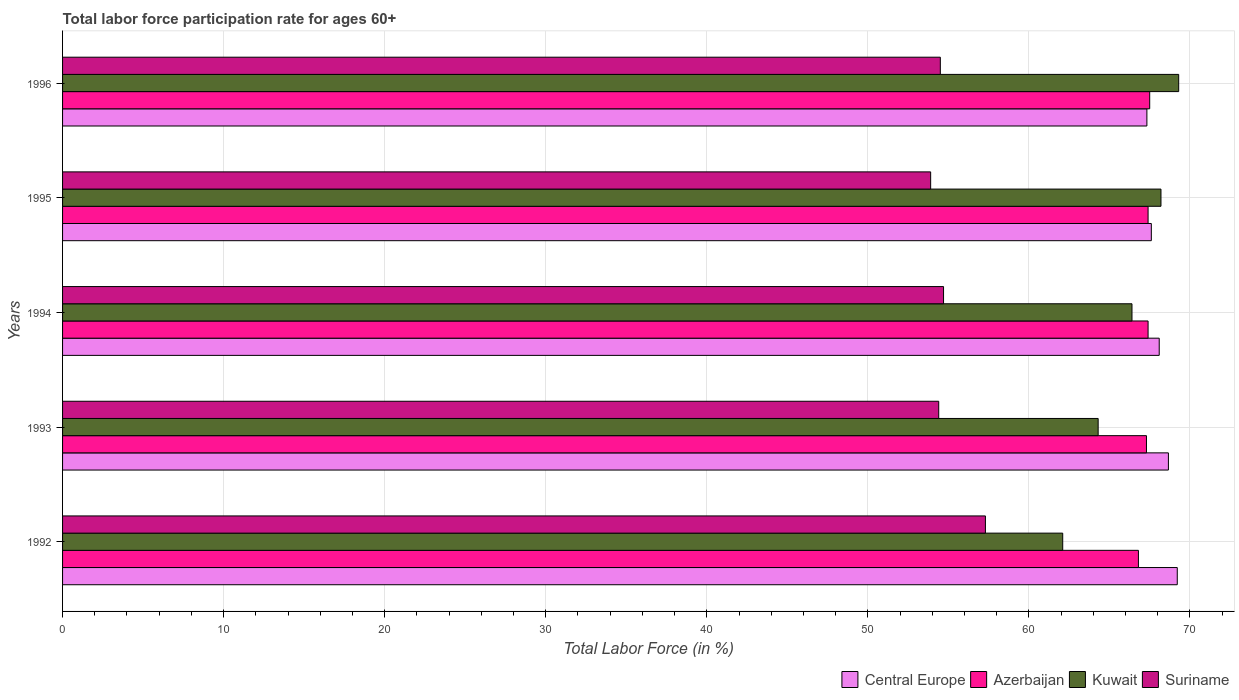How many different coloured bars are there?
Keep it short and to the point. 4. How many groups of bars are there?
Your response must be concise. 5. Are the number of bars per tick equal to the number of legend labels?
Offer a very short reply. Yes. How many bars are there on the 1st tick from the top?
Ensure brevity in your answer.  4. How many bars are there on the 3rd tick from the bottom?
Make the answer very short. 4. In how many cases, is the number of bars for a given year not equal to the number of legend labels?
Provide a succinct answer. 0. What is the labor force participation rate in Suriname in 1993?
Your answer should be very brief. 54.4. Across all years, what is the maximum labor force participation rate in Kuwait?
Make the answer very short. 69.3. Across all years, what is the minimum labor force participation rate in Suriname?
Your answer should be very brief. 53.9. In which year was the labor force participation rate in Kuwait maximum?
Provide a succinct answer. 1996. In which year was the labor force participation rate in Central Europe minimum?
Keep it short and to the point. 1996. What is the total labor force participation rate in Azerbaijan in the graph?
Your answer should be compact. 336.4. What is the difference between the labor force participation rate in Suriname in 1994 and that in 1996?
Provide a succinct answer. 0.2. What is the difference between the labor force participation rate in Kuwait in 1994 and the labor force participation rate in Central Europe in 1996?
Your response must be concise. -0.93. What is the average labor force participation rate in Central Europe per year?
Your answer should be very brief. 68.18. In the year 1996, what is the difference between the labor force participation rate in Azerbaijan and labor force participation rate in Suriname?
Your answer should be very brief. 13. In how many years, is the labor force participation rate in Central Europe greater than 38 %?
Offer a terse response. 5. What is the ratio of the labor force participation rate in Azerbaijan in 1992 to that in 1996?
Offer a very short reply. 0.99. Is the difference between the labor force participation rate in Azerbaijan in 1995 and 1996 greater than the difference between the labor force participation rate in Suriname in 1995 and 1996?
Provide a short and direct response. Yes. What is the difference between the highest and the second highest labor force participation rate in Central Europe?
Provide a short and direct response. 0.55. What is the difference between the highest and the lowest labor force participation rate in Kuwait?
Make the answer very short. 7.2. Is it the case that in every year, the sum of the labor force participation rate in Central Europe and labor force participation rate in Suriname is greater than the sum of labor force participation rate in Kuwait and labor force participation rate in Azerbaijan?
Your answer should be compact. Yes. What does the 3rd bar from the top in 1992 represents?
Make the answer very short. Azerbaijan. What does the 4th bar from the bottom in 1992 represents?
Offer a very short reply. Suriname. How many bars are there?
Offer a very short reply. 20. How many years are there in the graph?
Give a very brief answer. 5. What is the difference between two consecutive major ticks on the X-axis?
Ensure brevity in your answer.  10. Are the values on the major ticks of X-axis written in scientific E-notation?
Keep it short and to the point. No. Does the graph contain any zero values?
Offer a terse response. No. Does the graph contain grids?
Your answer should be compact. Yes. Where does the legend appear in the graph?
Your answer should be compact. Bottom right. How are the legend labels stacked?
Keep it short and to the point. Horizontal. What is the title of the graph?
Ensure brevity in your answer.  Total labor force participation rate for ages 60+. What is the label or title of the X-axis?
Make the answer very short. Total Labor Force (in %). What is the label or title of the Y-axis?
Make the answer very short. Years. What is the Total Labor Force (in %) of Central Europe in 1992?
Your answer should be very brief. 69.21. What is the Total Labor Force (in %) of Azerbaijan in 1992?
Offer a terse response. 66.8. What is the Total Labor Force (in %) in Kuwait in 1992?
Make the answer very short. 62.1. What is the Total Labor Force (in %) in Suriname in 1992?
Make the answer very short. 57.3. What is the Total Labor Force (in %) in Central Europe in 1993?
Your answer should be very brief. 68.66. What is the Total Labor Force (in %) in Azerbaijan in 1993?
Keep it short and to the point. 67.3. What is the Total Labor Force (in %) of Kuwait in 1993?
Your answer should be compact. 64.3. What is the Total Labor Force (in %) in Suriname in 1993?
Offer a terse response. 54.4. What is the Total Labor Force (in %) of Central Europe in 1994?
Your answer should be very brief. 68.09. What is the Total Labor Force (in %) of Azerbaijan in 1994?
Your response must be concise. 67.4. What is the Total Labor Force (in %) of Kuwait in 1994?
Give a very brief answer. 66.4. What is the Total Labor Force (in %) of Suriname in 1994?
Offer a terse response. 54.7. What is the Total Labor Force (in %) of Central Europe in 1995?
Keep it short and to the point. 67.6. What is the Total Labor Force (in %) of Azerbaijan in 1995?
Make the answer very short. 67.4. What is the Total Labor Force (in %) in Kuwait in 1995?
Your answer should be very brief. 68.2. What is the Total Labor Force (in %) of Suriname in 1995?
Keep it short and to the point. 53.9. What is the Total Labor Force (in %) of Central Europe in 1996?
Offer a terse response. 67.33. What is the Total Labor Force (in %) in Azerbaijan in 1996?
Provide a short and direct response. 67.5. What is the Total Labor Force (in %) in Kuwait in 1996?
Make the answer very short. 69.3. What is the Total Labor Force (in %) in Suriname in 1996?
Provide a succinct answer. 54.5. Across all years, what is the maximum Total Labor Force (in %) of Central Europe?
Your answer should be compact. 69.21. Across all years, what is the maximum Total Labor Force (in %) in Azerbaijan?
Offer a terse response. 67.5. Across all years, what is the maximum Total Labor Force (in %) of Kuwait?
Offer a terse response. 69.3. Across all years, what is the maximum Total Labor Force (in %) in Suriname?
Provide a short and direct response. 57.3. Across all years, what is the minimum Total Labor Force (in %) of Central Europe?
Keep it short and to the point. 67.33. Across all years, what is the minimum Total Labor Force (in %) of Azerbaijan?
Provide a succinct answer. 66.8. Across all years, what is the minimum Total Labor Force (in %) in Kuwait?
Offer a very short reply. 62.1. Across all years, what is the minimum Total Labor Force (in %) in Suriname?
Keep it short and to the point. 53.9. What is the total Total Labor Force (in %) in Central Europe in the graph?
Keep it short and to the point. 340.89. What is the total Total Labor Force (in %) in Azerbaijan in the graph?
Offer a terse response. 336.4. What is the total Total Labor Force (in %) of Kuwait in the graph?
Make the answer very short. 330.3. What is the total Total Labor Force (in %) in Suriname in the graph?
Offer a terse response. 274.8. What is the difference between the Total Labor Force (in %) in Central Europe in 1992 and that in 1993?
Your answer should be compact. 0.55. What is the difference between the Total Labor Force (in %) in Azerbaijan in 1992 and that in 1993?
Keep it short and to the point. -0.5. What is the difference between the Total Labor Force (in %) in Central Europe in 1992 and that in 1994?
Your answer should be compact. 1.12. What is the difference between the Total Labor Force (in %) in Azerbaijan in 1992 and that in 1994?
Keep it short and to the point. -0.6. What is the difference between the Total Labor Force (in %) of Kuwait in 1992 and that in 1994?
Offer a terse response. -4.3. What is the difference between the Total Labor Force (in %) of Central Europe in 1992 and that in 1995?
Your answer should be very brief. 1.61. What is the difference between the Total Labor Force (in %) in Kuwait in 1992 and that in 1995?
Offer a very short reply. -6.1. What is the difference between the Total Labor Force (in %) of Suriname in 1992 and that in 1995?
Your answer should be very brief. 3.4. What is the difference between the Total Labor Force (in %) in Central Europe in 1992 and that in 1996?
Provide a succinct answer. 1.89. What is the difference between the Total Labor Force (in %) of Azerbaijan in 1992 and that in 1996?
Make the answer very short. -0.7. What is the difference between the Total Labor Force (in %) in Central Europe in 1993 and that in 1994?
Your answer should be compact. 0.57. What is the difference between the Total Labor Force (in %) of Azerbaijan in 1993 and that in 1994?
Provide a short and direct response. -0.1. What is the difference between the Total Labor Force (in %) of Kuwait in 1993 and that in 1994?
Offer a very short reply. -2.1. What is the difference between the Total Labor Force (in %) of Suriname in 1993 and that in 1994?
Ensure brevity in your answer.  -0.3. What is the difference between the Total Labor Force (in %) of Central Europe in 1993 and that in 1995?
Offer a very short reply. 1.06. What is the difference between the Total Labor Force (in %) in Kuwait in 1993 and that in 1995?
Your answer should be very brief. -3.9. What is the difference between the Total Labor Force (in %) in Central Europe in 1993 and that in 1996?
Make the answer very short. 1.34. What is the difference between the Total Labor Force (in %) of Azerbaijan in 1993 and that in 1996?
Give a very brief answer. -0.2. What is the difference between the Total Labor Force (in %) in Kuwait in 1993 and that in 1996?
Your answer should be compact. -5. What is the difference between the Total Labor Force (in %) of Suriname in 1993 and that in 1996?
Ensure brevity in your answer.  -0.1. What is the difference between the Total Labor Force (in %) of Central Europe in 1994 and that in 1995?
Offer a very short reply. 0.49. What is the difference between the Total Labor Force (in %) of Kuwait in 1994 and that in 1995?
Keep it short and to the point. -1.8. What is the difference between the Total Labor Force (in %) of Central Europe in 1994 and that in 1996?
Offer a very short reply. 0.77. What is the difference between the Total Labor Force (in %) in Kuwait in 1994 and that in 1996?
Offer a very short reply. -2.9. What is the difference between the Total Labor Force (in %) of Suriname in 1994 and that in 1996?
Offer a very short reply. 0.2. What is the difference between the Total Labor Force (in %) of Central Europe in 1995 and that in 1996?
Offer a terse response. 0.28. What is the difference between the Total Labor Force (in %) in Azerbaijan in 1995 and that in 1996?
Provide a succinct answer. -0.1. What is the difference between the Total Labor Force (in %) in Central Europe in 1992 and the Total Labor Force (in %) in Azerbaijan in 1993?
Offer a very short reply. 1.91. What is the difference between the Total Labor Force (in %) in Central Europe in 1992 and the Total Labor Force (in %) in Kuwait in 1993?
Your response must be concise. 4.91. What is the difference between the Total Labor Force (in %) of Central Europe in 1992 and the Total Labor Force (in %) of Suriname in 1993?
Ensure brevity in your answer.  14.81. What is the difference between the Total Labor Force (in %) in Azerbaijan in 1992 and the Total Labor Force (in %) in Kuwait in 1993?
Provide a succinct answer. 2.5. What is the difference between the Total Labor Force (in %) in Azerbaijan in 1992 and the Total Labor Force (in %) in Suriname in 1993?
Keep it short and to the point. 12.4. What is the difference between the Total Labor Force (in %) in Central Europe in 1992 and the Total Labor Force (in %) in Azerbaijan in 1994?
Offer a very short reply. 1.81. What is the difference between the Total Labor Force (in %) of Central Europe in 1992 and the Total Labor Force (in %) of Kuwait in 1994?
Give a very brief answer. 2.81. What is the difference between the Total Labor Force (in %) in Central Europe in 1992 and the Total Labor Force (in %) in Suriname in 1994?
Make the answer very short. 14.51. What is the difference between the Total Labor Force (in %) of Central Europe in 1992 and the Total Labor Force (in %) of Azerbaijan in 1995?
Your answer should be very brief. 1.81. What is the difference between the Total Labor Force (in %) in Central Europe in 1992 and the Total Labor Force (in %) in Suriname in 1995?
Keep it short and to the point. 15.31. What is the difference between the Total Labor Force (in %) in Central Europe in 1992 and the Total Labor Force (in %) in Azerbaijan in 1996?
Keep it short and to the point. 1.71. What is the difference between the Total Labor Force (in %) of Central Europe in 1992 and the Total Labor Force (in %) of Kuwait in 1996?
Make the answer very short. -0.09. What is the difference between the Total Labor Force (in %) of Central Europe in 1992 and the Total Labor Force (in %) of Suriname in 1996?
Ensure brevity in your answer.  14.71. What is the difference between the Total Labor Force (in %) in Azerbaijan in 1992 and the Total Labor Force (in %) in Suriname in 1996?
Ensure brevity in your answer.  12.3. What is the difference between the Total Labor Force (in %) of Kuwait in 1992 and the Total Labor Force (in %) of Suriname in 1996?
Offer a terse response. 7.6. What is the difference between the Total Labor Force (in %) of Central Europe in 1993 and the Total Labor Force (in %) of Azerbaijan in 1994?
Make the answer very short. 1.26. What is the difference between the Total Labor Force (in %) in Central Europe in 1993 and the Total Labor Force (in %) in Kuwait in 1994?
Offer a very short reply. 2.26. What is the difference between the Total Labor Force (in %) of Central Europe in 1993 and the Total Labor Force (in %) of Suriname in 1994?
Provide a short and direct response. 13.96. What is the difference between the Total Labor Force (in %) in Azerbaijan in 1993 and the Total Labor Force (in %) in Kuwait in 1994?
Make the answer very short. 0.9. What is the difference between the Total Labor Force (in %) of Azerbaijan in 1993 and the Total Labor Force (in %) of Suriname in 1994?
Keep it short and to the point. 12.6. What is the difference between the Total Labor Force (in %) of Central Europe in 1993 and the Total Labor Force (in %) of Azerbaijan in 1995?
Provide a short and direct response. 1.26. What is the difference between the Total Labor Force (in %) in Central Europe in 1993 and the Total Labor Force (in %) in Kuwait in 1995?
Ensure brevity in your answer.  0.46. What is the difference between the Total Labor Force (in %) in Central Europe in 1993 and the Total Labor Force (in %) in Suriname in 1995?
Your answer should be very brief. 14.76. What is the difference between the Total Labor Force (in %) of Kuwait in 1993 and the Total Labor Force (in %) of Suriname in 1995?
Keep it short and to the point. 10.4. What is the difference between the Total Labor Force (in %) in Central Europe in 1993 and the Total Labor Force (in %) in Azerbaijan in 1996?
Provide a short and direct response. 1.16. What is the difference between the Total Labor Force (in %) in Central Europe in 1993 and the Total Labor Force (in %) in Kuwait in 1996?
Provide a succinct answer. -0.64. What is the difference between the Total Labor Force (in %) of Central Europe in 1993 and the Total Labor Force (in %) of Suriname in 1996?
Make the answer very short. 14.16. What is the difference between the Total Labor Force (in %) of Azerbaijan in 1993 and the Total Labor Force (in %) of Suriname in 1996?
Your response must be concise. 12.8. What is the difference between the Total Labor Force (in %) in Central Europe in 1994 and the Total Labor Force (in %) in Azerbaijan in 1995?
Your response must be concise. 0.69. What is the difference between the Total Labor Force (in %) of Central Europe in 1994 and the Total Labor Force (in %) of Kuwait in 1995?
Ensure brevity in your answer.  -0.11. What is the difference between the Total Labor Force (in %) of Central Europe in 1994 and the Total Labor Force (in %) of Suriname in 1995?
Provide a succinct answer. 14.19. What is the difference between the Total Labor Force (in %) of Azerbaijan in 1994 and the Total Labor Force (in %) of Kuwait in 1995?
Your answer should be very brief. -0.8. What is the difference between the Total Labor Force (in %) in Azerbaijan in 1994 and the Total Labor Force (in %) in Suriname in 1995?
Offer a terse response. 13.5. What is the difference between the Total Labor Force (in %) of Central Europe in 1994 and the Total Labor Force (in %) of Azerbaijan in 1996?
Your response must be concise. 0.59. What is the difference between the Total Labor Force (in %) in Central Europe in 1994 and the Total Labor Force (in %) in Kuwait in 1996?
Provide a succinct answer. -1.21. What is the difference between the Total Labor Force (in %) in Central Europe in 1994 and the Total Labor Force (in %) in Suriname in 1996?
Make the answer very short. 13.59. What is the difference between the Total Labor Force (in %) of Central Europe in 1995 and the Total Labor Force (in %) of Azerbaijan in 1996?
Your answer should be very brief. 0.1. What is the difference between the Total Labor Force (in %) in Central Europe in 1995 and the Total Labor Force (in %) in Kuwait in 1996?
Your answer should be very brief. -1.7. What is the difference between the Total Labor Force (in %) of Central Europe in 1995 and the Total Labor Force (in %) of Suriname in 1996?
Keep it short and to the point. 13.1. What is the difference between the Total Labor Force (in %) of Azerbaijan in 1995 and the Total Labor Force (in %) of Kuwait in 1996?
Offer a very short reply. -1.9. What is the difference between the Total Labor Force (in %) of Azerbaijan in 1995 and the Total Labor Force (in %) of Suriname in 1996?
Offer a very short reply. 12.9. What is the difference between the Total Labor Force (in %) of Kuwait in 1995 and the Total Labor Force (in %) of Suriname in 1996?
Your answer should be compact. 13.7. What is the average Total Labor Force (in %) of Central Europe per year?
Offer a very short reply. 68.18. What is the average Total Labor Force (in %) in Azerbaijan per year?
Offer a very short reply. 67.28. What is the average Total Labor Force (in %) of Kuwait per year?
Your answer should be compact. 66.06. What is the average Total Labor Force (in %) in Suriname per year?
Ensure brevity in your answer.  54.96. In the year 1992, what is the difference between the Total Labor Force (in %) in Central Europe and Total Labor Force (in %) in Azerbaijan?
Provide a succinct answer. 2.41. In the year 1992, what is the difference between the Total Labor Force (in %) in Central Europe and Total Labor Force (in %) in Kuwait?
Ensure brevity in your answer.  7.11. In the year 1992, what is the difference between the Total Labor Force (in %) of Central Europe and Total Labor Force (in %) of Suriname?
Your answer should be very brief. 11.91. In the year 1992, what is the difference between the Total Labor Force (in %) of Azerbaijan and Total Labor Force (in %) of Suriname?
Make the answer very short. 9.5. In the year 1992, what is the difference between the Total Labor Force (in %) in Kuwait and Total Labor Force (in %) in Suriname?
Provide a succinct answer. 4.8. In the year 1993, what is the difference between the Total Labor Force (in %) in Central Europe and Total Labor Force (in %) in Azerbaijan?
Your answer should be compact. 1.36. In the year 1993, what is the difference between the Total Labor Force (in %) in Central Europe and Total Labor Force (in %) in Kuwait?
Provide a succinct answer. 4.36. In the year 1993, what is the difference between the Total Labor Force (in %) in Central Europe and Total Labor Force (in %) in Suriname?
Keep it short and to the point. 14.26. In the year 1993, what is the difference between the Total Labor Force (in %) in Azerbaijan and Total Labor Force (in %) in Suriname?
Your answer should be very brief. 12.9. In the year 1994, what is the difference between the Total Labor Force (in %) of Central Europe and Total Labor Force (in %) of Azerbaijan?
Give a very brief answer. 0.69. In the year 1994, what is the difference between the Total Labor Force (in %) in Central Europe and Total Labor Force (in %) in Kuwait?
Offer a very short reply. 1.69. In the year 1994, what is the difference between the Total Labor Force (in %) of Central Europe and Total Labor Force (in %) of Suriname?
Your response must be concise. 13.39. In the year 1994, what is the difference between the Total Labor Force (in %) in Azerbaijan and Total Labor Force (in %) in Suriname?
Keep it short and to the point. 12.7. In the year 1995, what is the difference between the Total Labor Force (in %) in Central Europe and Total Labor Force (in %) in Azerbaijan?
Your answer should be compact. 0.2. In the year 1995, what is the difference between the Total Labor Force (in %) of Central Europe and Total Labor Force (in %) of Kuwait?
Provide a short and direct response. -0.6. In the year 1995, what is the difference between the Total Labor Force (in %) in Central Europe and Total Labor Force (in %) in Suriname?
Offer a terse response. 13.7. In the year 1995, what is the difference between the Total Labor Force (in %) in Azerbaijan and Total Labor Force (in %) in Suriname?
Your answer should be very brief. 13.5. In the year 1995, what is the difference between the Total Labor Force (in %) of Kuwait and Total Labor Force (in %) of Suriname?
Ensure brevity in your answer.  14.3. In the year 1996, what is the difference between the Total Labor Force (in %) in Central Europe and Total Labor Force (in %) in Azerbaijan?
Your answer should be compact. -0.17. In the year 1996, what is the difference between the Total Labor Force (in %) in Central Europe and Total Labor Force (in %) in Kuwait?
Provide a short and direct response. -1.97. In the year 1996, what is the difference between the Total Labor Force (in %) of Central Europe and Total Labor Force (in %) of Suriname?
Make the answer very short. 12.83. In the year 1996, what is the difference between the Total Labor Force (in %) of Azerbaijan and Total Labor Force (in %) of Suriname?
Offer a very short reply. 13. In the year 1996, what is the difference between the Total Labor Force (in %) in Kuwait and Total Labor Force (in %) in Suriname?
Make the answer very short. 14.8. What is the ratio of the Total Labor Force (in %) in Azerbaijan in 1992 to that in 1993?
Your answer should be very brief. 0.99. What is the ratio of the Total Labor Force (in %) in Kuwait in 1992 to that in 1993?
Keep it short and to the point. 0.97. What is the ratio of the Total Labor Force (in %) of Suriname in 1992 to that in 1993?
Provide a short and direct response. 1.05. What is the ratio of the Total Labor Force (in %) of Central Europe in 1992 to that in 1994?
Provide a succinct answer. 1.02. What is the ratio of the Total Labor Force (in %) of Kuwait in 1992 to that in 1994?
Your answer should be compact. 0.94. What is the ratio of the Total Labor Force (in %) in Suriname in 1992 to that in 1994?
Provide a short and direct response. 1.05. What is the ratio of the Total Labor Force (in %) in Central Europe in 1992 to that in 1995?
Make the answer very short. 1.02. What is the ratio of the Total Labor Force (in %) of Azerbaijan in 1992 to that in 1995?
Your answer should be compact. 0.99. What is the ratio of the Total Labor Force (in %) of Kuwait in 1992 to that in 1995?
Provide a short and direct response. 0.91. What is the ratio of the Total Labor Force (in %) of Suriname in 1992 to that in 1995?
Ensure brevity in your answer.  1.06. What is the ratio of the Total Labor Force (in %) in Central Europe in 1992 to that in 1996?
Your response must be concise. 1.03. What is the ratio of the Total Labor Force (in %) of Azerbaijan in 1992 to that in 1996?
Your answer should be compact. 0.99. What is the ratio of the Total Labor Force (in %) of Kuwait in 1992 to that in 1996?
Keep it short and to the point. 0.9. What is the ratio of the Total Labor Force (in %) of Suriname in 1992 to that in 1996?
Make the answer very short. 1.05. What is the ratio of the Total Labor Force (in %) of Central Europe in 1993 to that in 1994?
Give a very brief answer. 1.01. What is the ratio of the Total Labor Force (in %) of Azerbaijan in 1993 to that in 1994?
Give a very brief answer. 1. What is the ratio of the Total Labor Force (in %) in Kuwait in 1993 to that in 1994?
Your answer should be very brief. 0.97. What is the ratio of the Total Labor Force (in %) of Suriname in 1993 to that in 1994?
Your answer should be very brief. 0.99. What is the ratio of the Total Labor Force (in %) of Central Europe in 1993 to that in 1995?
Your answer should be very brief. 1.02. What is the ratio of the Total Labor Force (in %) of Kuwait in 1993 to that in 1995?
Offer a terse response. 0.94. What is the ratio of the Total Labor Force (in %) in Suriname in 1993 to that in 1995?
Offer a terse response. 1.01. What is the ratio of the Total Labor Force (in %) of Central Europe in 1993 to that in 1996?
Offer a very short reply. 1.02. What is the ratio of the Total Labor Force (in %) of Azerbaijan in 1993 to that in 1996?
Your answer should be very brief. 1. What is the ratio of the Total Labor Force (in %) in Kuwait in 1993 to that in 1996?
Provide a short and direct response. 0.93. What is the ratio of the Total Labor Force (in %) in Suriname in 1993 to that in 1996?
Keep it short and to the point. 1. What is the ratio of the Total Labor Force (in %) in Azerbaijan in 1994 to that in 1995?
Your response must be concise. 1. What is the ratio of the Total Labor Force (in %) of Kuwait in 1994 to that in 1995?
Keep it short and to the point. 0.97. What is the ratio of the Total Labor Force (in %) in Suriname in 1994 to that in 1995?
Provide a succinct answer. 1.01. What is the ratio of the Total Labor Force (in %) of Central Europe in 1994 to that in 1996?
Offer a very short reply. 1.01. What is the ratio of the Total Labor Force (in %) of Azerbaijan in 1994 to that in 1996?
Provide a succinct answer. 1. What is the ratio of the Total Labor Force (in %) of Kuwait in 1994 to that in 1996?
Give a very brief answer. 0.96. What is the ratio of the Total Labor Force (in %) of Kuwait in 1995 to that in 1996?
Ensure brevity in your answer.  0.98. What is the difference between the highest and the second highest Total Labor Force (in %) of Central Europe?
Give a very brief answer. 0.55. What is the difference between the highest and the second highest Total Labor Force (in %) of Kuwait?
Provide a succinct answer. 1.1. What is the difference between the highest and the second highest Total Labor Force (in %) of Suriname?
Give a very brief answer. 2.6. What is the difference between the highest and the lowest Total Labor Force (in %) in Central Europe?
Your answer should be compact. 1.89. What is the difference between the highest and the lowest Total Labor Force (in %) in Azerbaijan?
Your answer should be very brief. 0.7. What is the difference between the highest and the lowest Total Labor Force (in %) of Kuwait?
Offer a terse response. 7.2. What is the difference between the highest and the lowest Total Labor Force (in %) of Suriname?
Give a very brief answer. 3.4. 